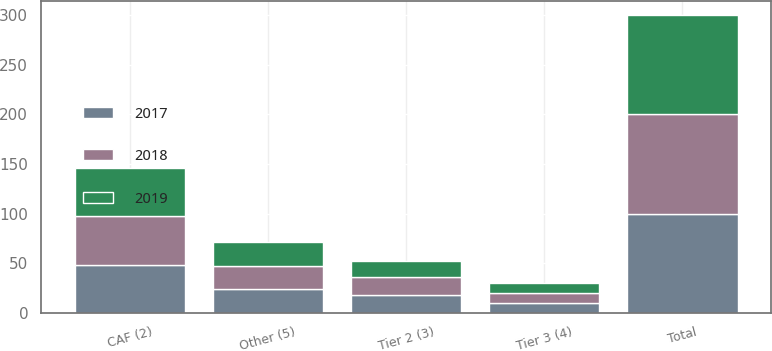Convert chart. <chart><loc_0><loc_0><loc_500><loc_500><stacked_bar_chart><ecel><fcel>CAF (2)<fcel>Tier 2 (3)<fcel>Tier 3 (4)<fcel>Other (5)<fcel>Total<nl><fcel>2017<fcel>48.4<fcel>17.9<fcel>9.9<fcel>23.8<fcel>100<nl><fcel>2019<fcel>48.4<fcel>16.6<fcel>10.5<fcel>24.5<fcel>100<nl><fcel>2018<fcel>49.5<fcel>17.8<fcel>9.8<fcel>22.9<fcel>100<nl></chart> 